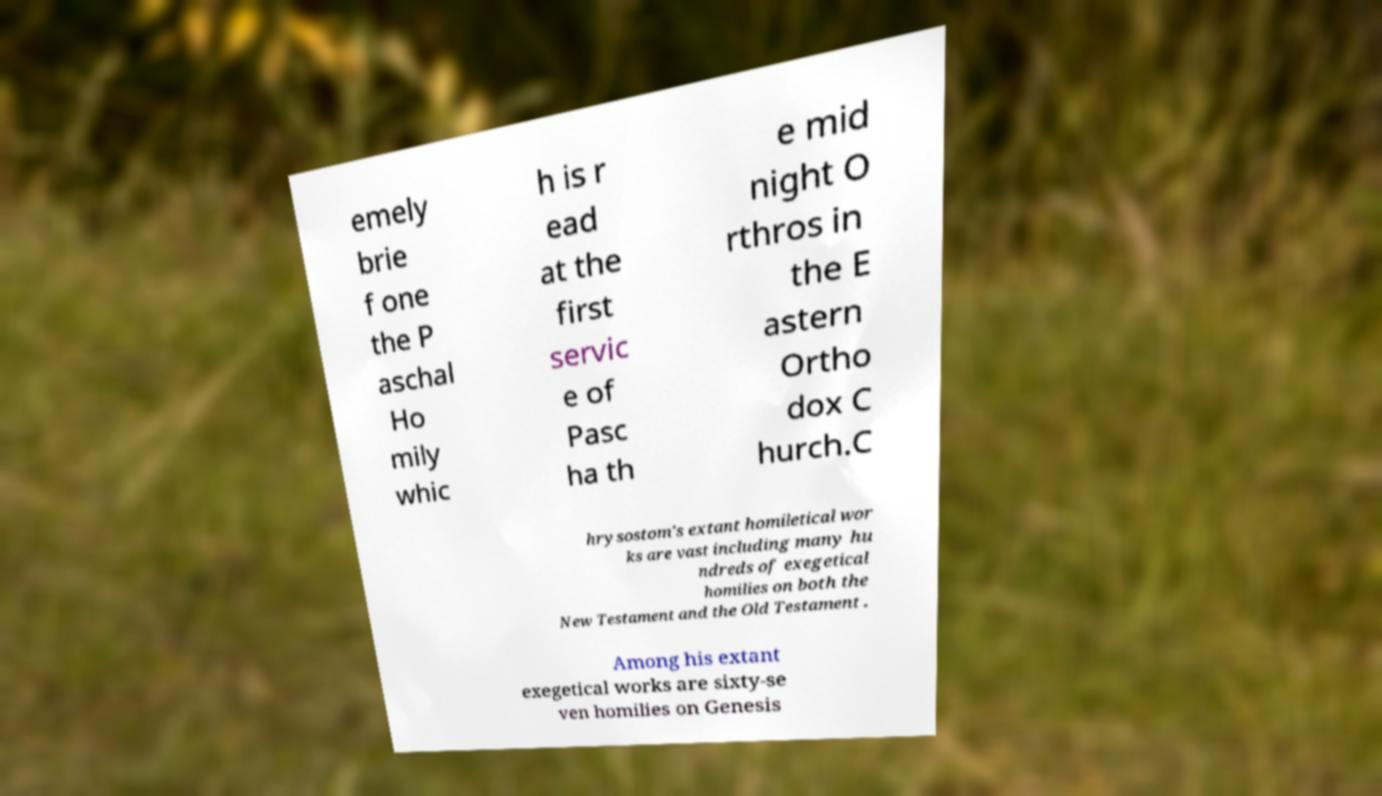Can you accurately transcribe the text from the provided image for me? emely brie f one the P aschal Ho mily whic h is r ead at the first servic e of Pasc ha th e mid night O rthros in the E astern Ortho dox C hurch.C hrysostom's extant homiletical wor ks are vast including many hu ndreds of exegetical homilies on both the New Testament and the Old Testament . Among his extant exegetical works are sixty-se ven homilies on Genesis 